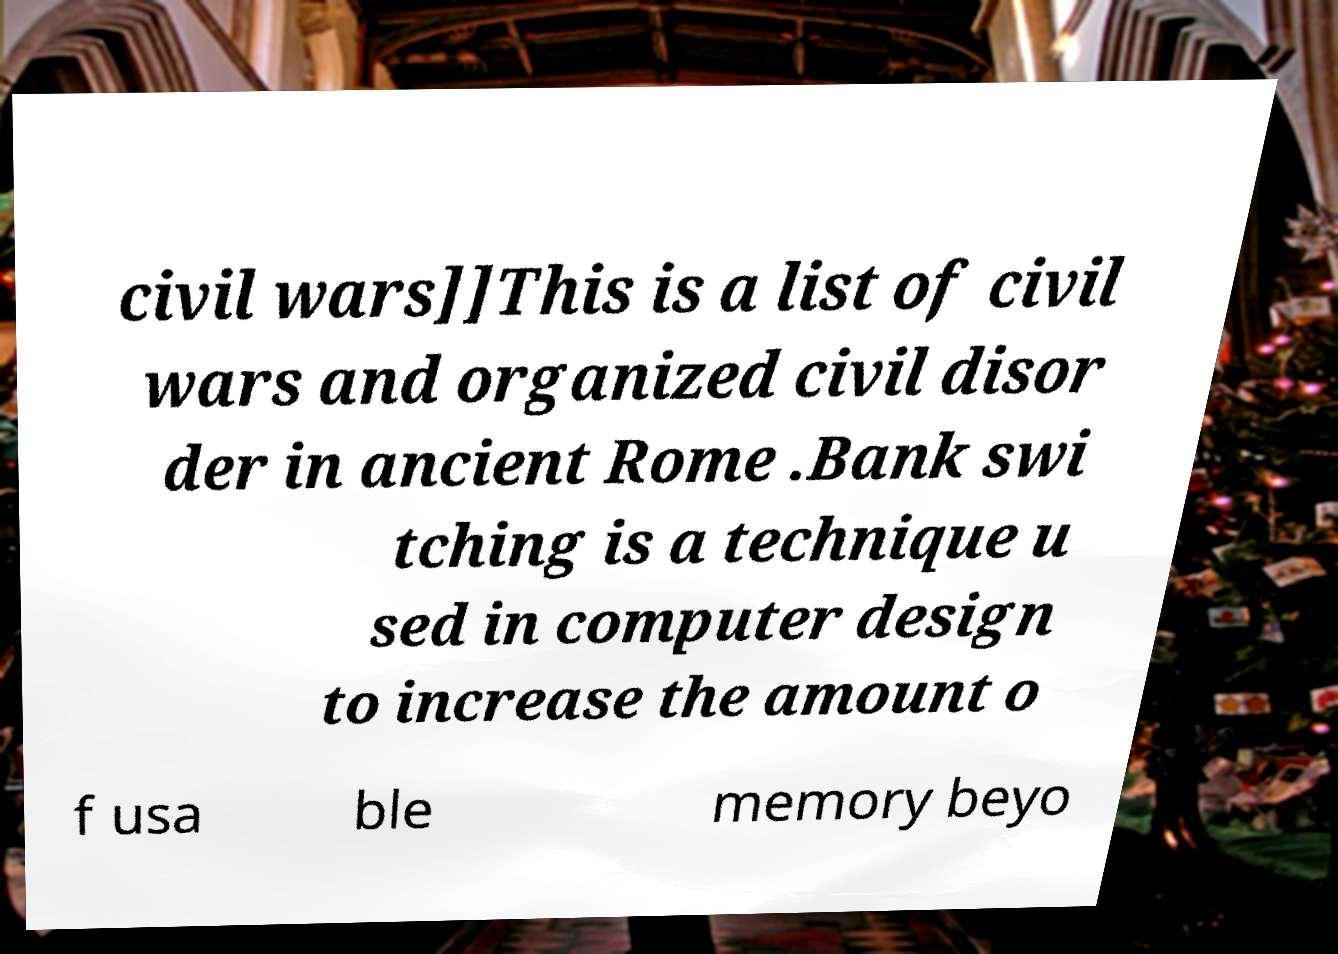I need the written content from this picture converted into text. Can you do that? civil wars]]This is a list of civil wars and organized civil disor der in ancient Rome .Bank swi tching is a technique u sed in computer design to increase the amount o f usa ble memory beyo 